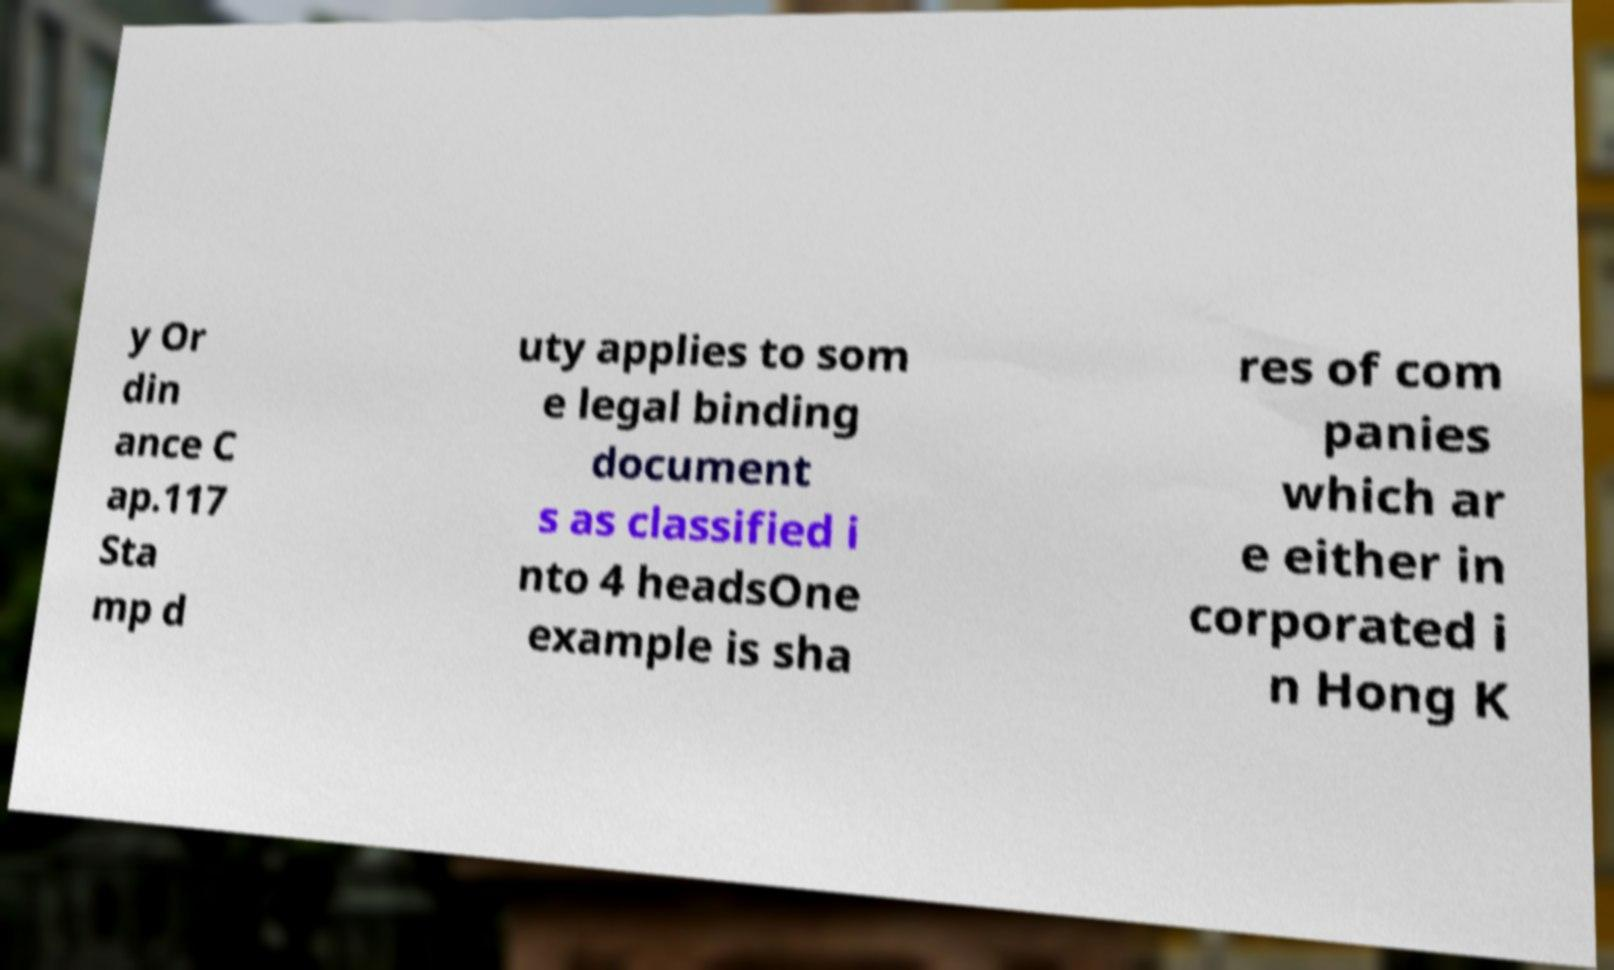Can you read and provide the text displayed in the image?This photo seems to have some interesting text. Can you extract and type it out for me? y Or din ance C ap.117 Sta mp d uty applies to som e legal binding document s as classified i nto 4 headsOne example is sha res of com panies which ar e either in corporated i n Hong K 